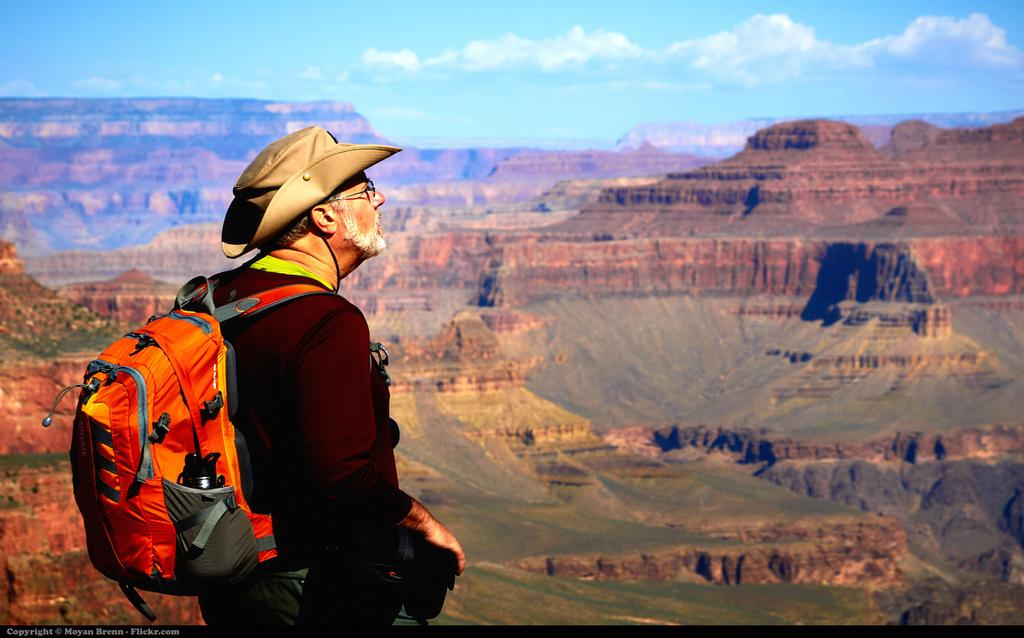What is the man in the image wearing? The man is wearing a jacket, a hat, and glasses (specs). What is the man holding in the image? The man is holding a camera and a bag. What can be seen in the background of the image? There is a hill and sky visible in the background of the image. What is the condition of the sky in the image? The sky has clouds in it. What type of thumb can be seen holding the camera in the image? There is no thumb visible in the image; the man is holding the camera with his hand. What type of vessel is the man using to carry the camera in the image? The man is not using a vessel to carry the camera; he is holding it directly. 